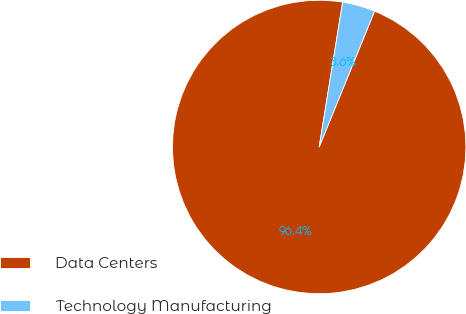Convert chart. <chart><loc_0><loc_0><loc_500><loc_500><pie_chart><fcel>Data Centers<fcel>Technology Manufacturing<nl><fcel>96.39%<fcel>3.61%<nl></chart> 